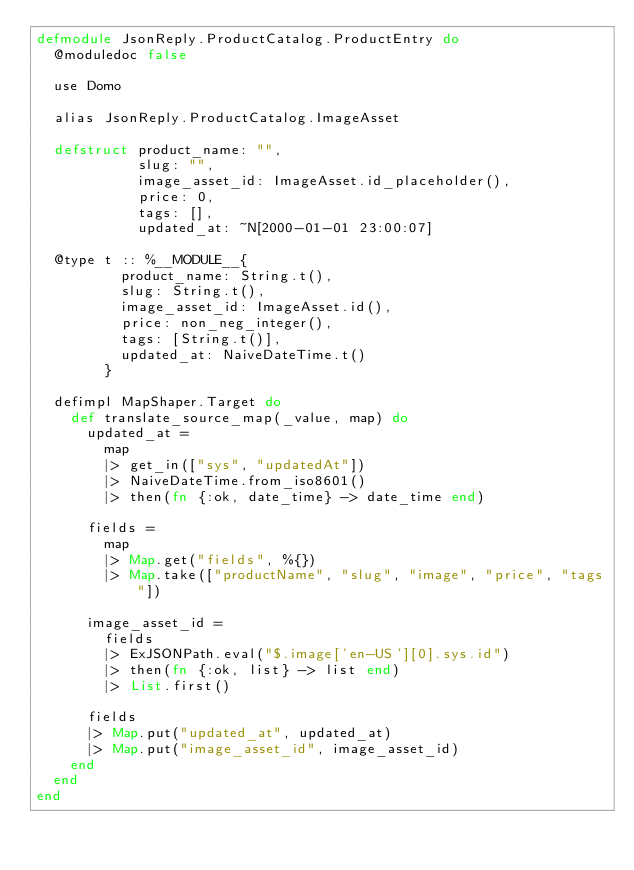<code> <loc_0><loc_0><loc_500><loc_500><_Elixir_>defmodule JsonReply.ProductCatalog.ProductEntry do
  @moduledoc false

  use Domo

  alias JsonReply.ProductCatalog.ImageAsset

  defstruct product_name: "",
            slug: "",
            image_asset_id: ImageAsset.id_placeholder(),
            price: 0,
            tags: [],
            updated_at: ~N[2000-01-01 23:00:07]

  @type t :: %__MODULE__{
          product_name: String.t(),
          slug: String.t(),
          image_asset_id: ImageAsset.id(),
          price: non_neg_integer(),
          tags: [String.t()],
          updated_at: NaiveDateTime.t()
        }

  defimpl MapShaper.Target do
    def translate_source_map(_value, map) do
      updated_at =
        map
        |> get_in(["sys", "updatedAt"])
        |> NaiveDateTime.from_iso8601()
        |> then(fn {:ok, date_time} -> date_time end)

      fields =
        map
        |> Map.get("fields", %{})
        |> Map.take(["productName", "slug", "image", "price", "tags"])

      image_asset_id =
        fields
        |> ExJSONPath.eval("$.image['en-US'][0].sys.id")
        |> then(fn {:ok, list} -> list end)
        |> List.first()

      fields
      |> Map.put("updated_at", updated_at)
      |> Map.put("image_asset_id", image_asset_id)
    end
  end
end
</code> 